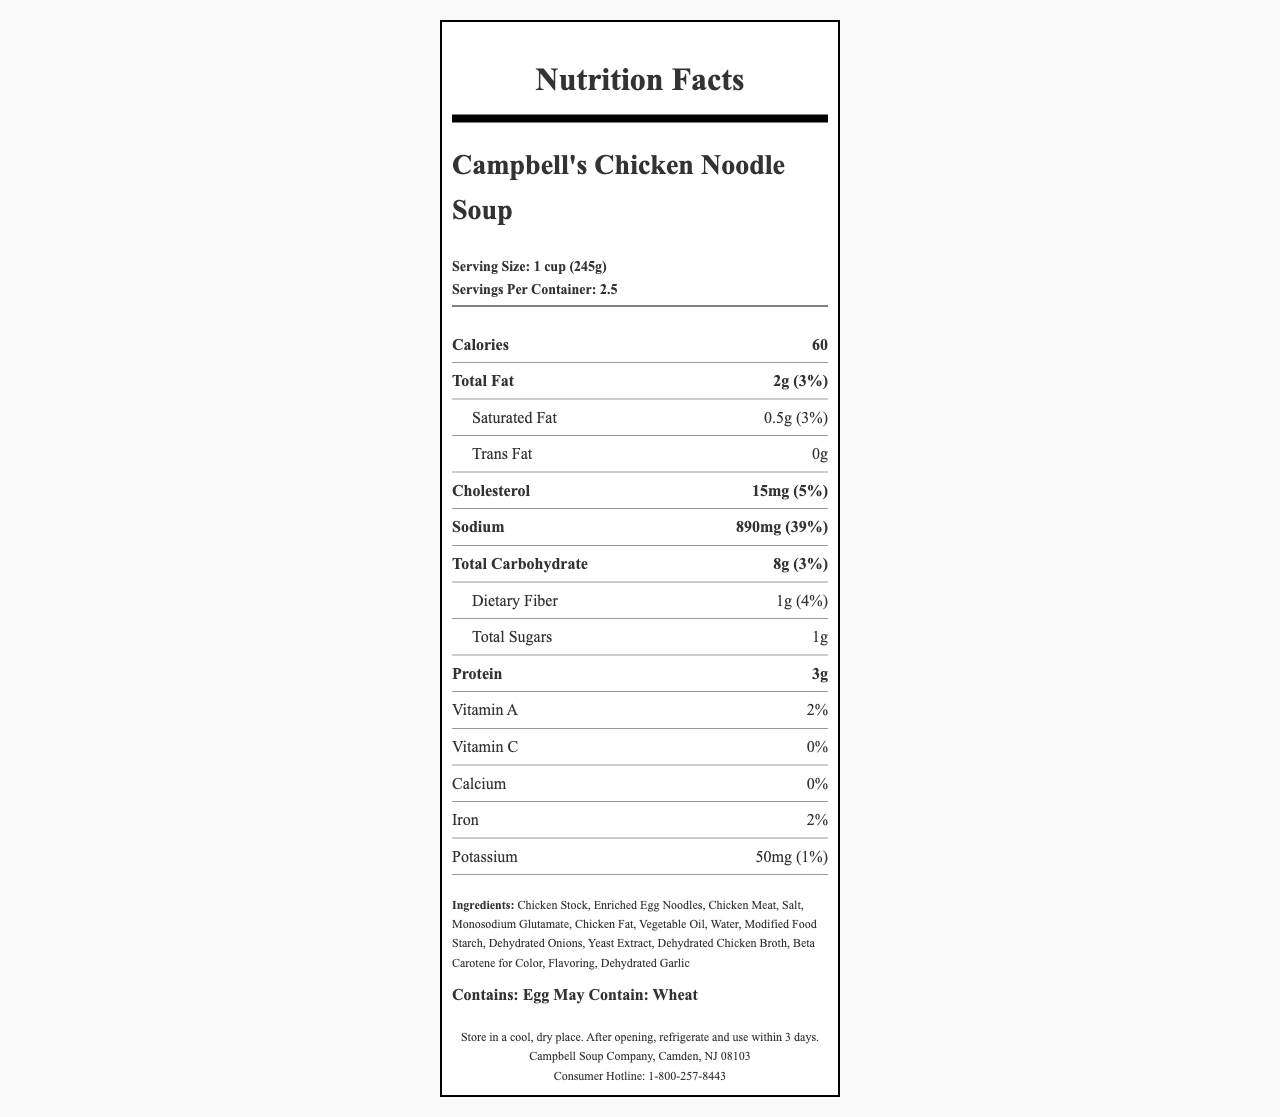What is the serving size for Campbell's Chicken Noodle Soup? The serving size is prominently displayed at the top of the document in the "serving-info" section.
Answer: 1 cup (245g) How many servings are there in one container? The "servings per container" is listed right below the serving size information.
Answer: 2.5 What is the amount of sodium per serving? The sodium content per serving is provided in the nutrient row labeled "Sodium".
Answer: 890mg What percentage of the daily value of sodium does one serving contain? The daily value percentage for sodium is shown alongside the sodium amount in the nutrient row.
Answer: 39% How many grams of total fat are in one serving? The total fat content is listed in the nutrient row labeled "Total Fat".
Answer: 2g What is the daily value percentage of saturated fat per serving? The daily value percentage for saturated fat is shown next to the amount in the row labeled "Saturated Fat".
Answer: 3% Which ingredient is listed first? Ingredients are listed in order of weight, and "Chicken Stock" is the first ingredient mentioned.
Answer: Chicken Stock How should the soup be stored after opening? The storage instructions are provided in the footer section of the document.
Answer: Refrigerate and use within 3 days How many calories are in one serving of this soup? The calorie content per serving is displayed in the bold nutrient row labeled "Calories".
Answer: 60 calories What is the amount of protein per serving? The protein content is listed in the nutrient row labeled "Protein".
Answer: 3g How much potassium does one serving contain? The potassium content per serving is listed at the bottom of the nutrient rows alongside its daily value percentage.
Answer: 50mg Which allergen is explicitly stated to be contained in the soup? The allergens section specifies that the soup contains egg.
Answer: Egg How many grams of dietary fiber are in one serving? A. 0g B. 0.5g C. 1g D. 2g The nutrient row for "Dietary Fiber" provides the amount as 1g.
Answer: C What is the percentage of daily value for iron per serving? A. 1% B. 2% C. 5% D. 10% The nutrient row for "Iron" indicates that it contains 2% of the daily value.
Answer: B Is there any trans fat in Campbell's Chicken Noodle Soup? The nutrient row for "Trans Fat" indicates that it has 0g of trans fat.
Answer: No Does the soup contain monosodium glutamate (MSG)? MSG is listed among the ingredients in the ingredients section.
Answer: Yes What is the main idea of this document? The document is a standardized Nutrition Facts Label that details various nutrient amounts and percentages, ingredients, allergens, storage instructions, and manufacturer information for Campbell's Chicken Noodle Soup.
Answer: The document provides detailed nutritional information for Campbell's Chicken Noodle Soup, including serving size, calorie content, and daily value percentages of various nutrients, along with ingredient and allergen information. What are the contact details for consumer inquiries? The consumer hotline number is listed in the footer section of the document.
Answer: 1-800-257-8443 What specific type of noodle is included in the ingredients? The ingredients list mentions "Enriched Egg Noodles."
Answer: Enriched Egg Noodles How many calories come from fat in one serving? The document provides the total calories and total fat in grams, but not the specific calorie amount from fat.
Answer: Not enough information 